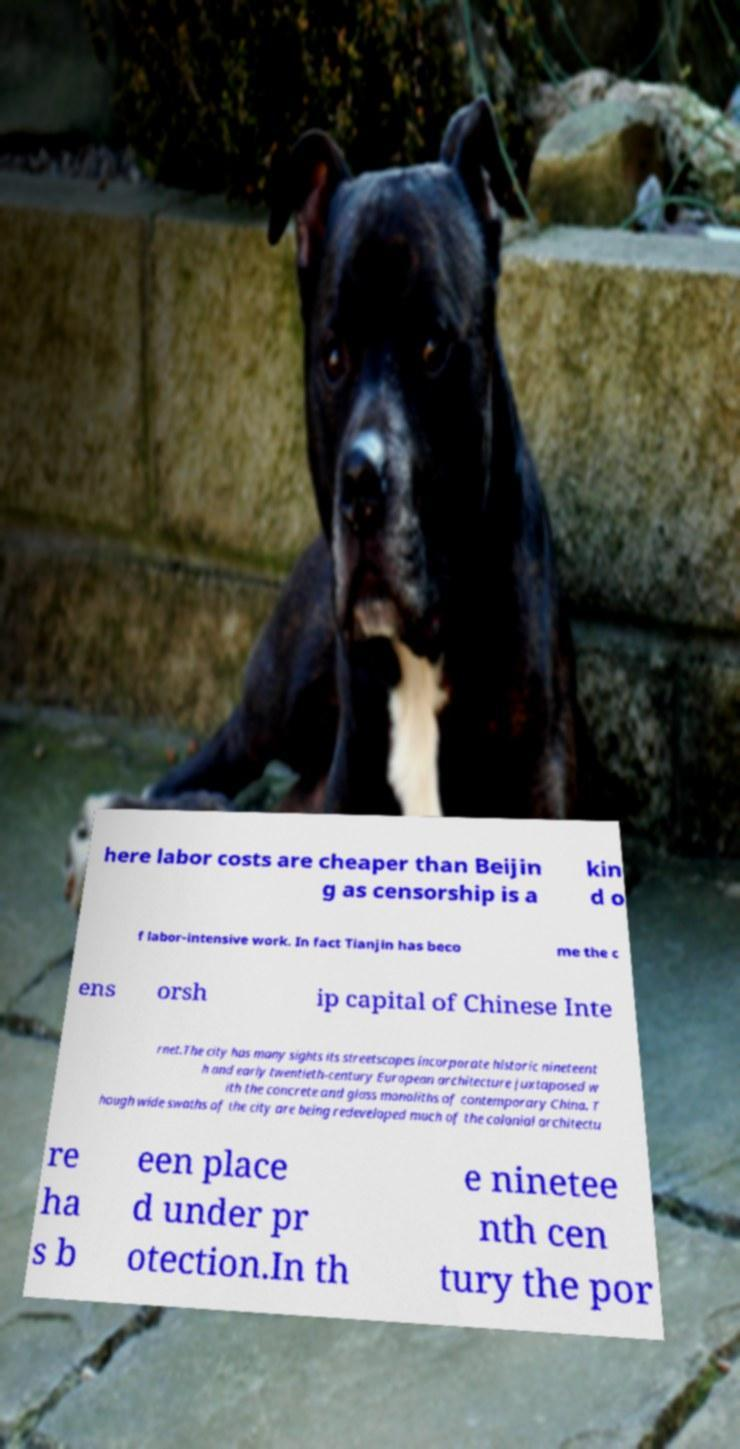For documentation purposes, I need the text within this image transcribed. Could you provide that? here labor costs are cheaper than Beijin g as censorship is a kin d o f labor-intensive work. In fact Tianjin has beco me the c ens orsh ip capital of Chinese Inte rnet.The city has many sights its streetscapes incorporate historic nineteent h and early twentieth-century European architecture juxtaposed w ith the concrete and glass monoliths of contemporary China. T hough wide swaths of the city are being redeveloped much of the colonial architectu re ha s b een place d under pr otection.In th e ninetee nth cen tury the por 